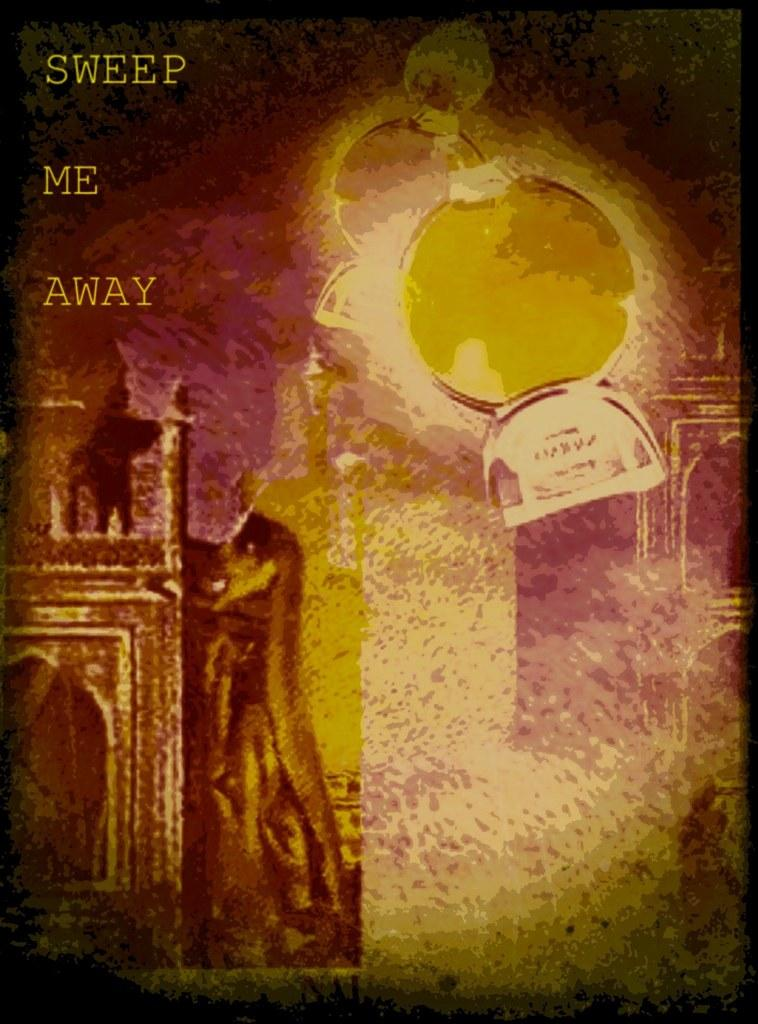<image>
Provide a brief description of the given image. A gold and purple colored poster has the phrase Sweep Me Away on it. 